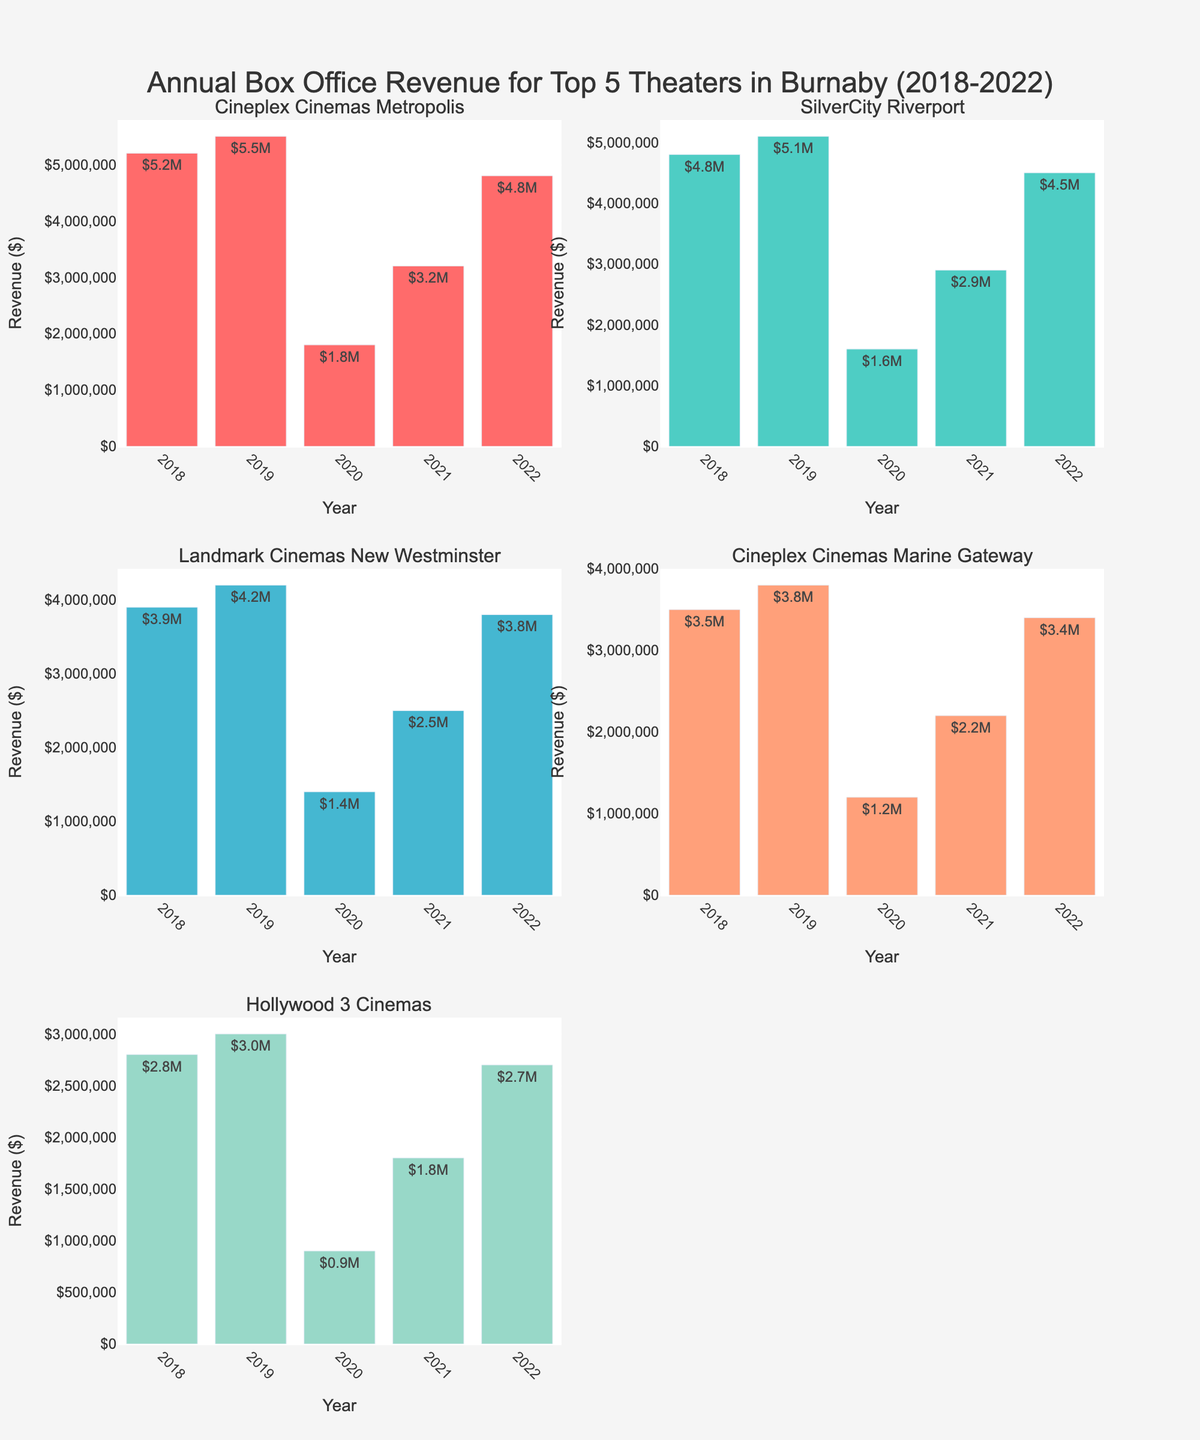What's the title of the figure? The title is placed at the top center of the figure, and it reads: "Annual Box Office Revenue for Top 5 Theaters in Burnaby (2018-2022)".
Answer: Annual Box Office Revenue for Top 5 Theaters in Burnaby (2018-2022) Which theater had the highest revenue in 2019? By looking at the height of the bars for the year 2019, we can see that the highest revenue was from Cineplex Cinemas Metropolis.
Answer: Cineplex Cinemas Metropolis What trend is visible for all theaters in 2020? The bars for all theaters in the year 2020 are significantly lower than in other years, indicating a drop in revenue for all theaters.
Answer: Drop in revenue How does Cineplex Cinemas Marine Gateway's revenue in 2022 compare to its revenue in 2018? The revenue in 2022 is $3.4M, and in 2018 it is $3.5M. The revenue has slightly decreased over these years.
Answer: Slight decrease Which theater saw the largest recovery in revenue from 2020 to 2022? Calculate the difference in revenue from 2020 to 2022 for each theater. The largest difference is for Cineplex Cinemas Metropolis, with an increase from $1.8M to $4.8M, a $3M increase.
Answer: Cineplex Cinemas Metropolis Compare the revenue trend of Hollywood 3 Cinemas and SilverCity Riverport from 2018 to 2022? Hollywood 3 Cinemas: revenue decreases in 2020 and rises gradually again by 2022. SilverCity Riverport: similar dip in 2020 but rebounds more steadily by 2022. Both follow a U-shaped pattern.
Answer: U-shaped pattern for both What was the total revenue of Landmark Cinemas New Westminster over the 5 years? Sum the revenues from 2018 to 2022: $3.9M + $4.2M + $1.4M + $2.5M + $3.8M = $15.8M.
Answer: $15.8M Which theater showed the least amount of revenue change over the 5 years? By examining all bars, Cineplex Cinemas Marine Gateway showed relatively small changes in revenue compared to other theaters.
Answer: Cineplex Cinemas Marine Gateway How did SilverCity Riverport perform in 2021 compared to Cineplex Cinemas Metropolis in the same year? In 2021, SilverCity Riverport had a revenue of $2.9M, while Cineplex Cinemas Metropolis had $3.2M. Thus, Cineplex Cinemas Metropolis performed slightly better.
Answer: Cineplex Cinemas Metropolis performed better What was the average annual revenue for Hollywood 3 Cinemas over the 5 years? Sum all revenues for Hollywood 3 Cinemas and divide by 5: ($2.8M + $3.0M + $0.9M + $1.8M + $2.7M) / 5 = $2.24M.
Answer: $2.24M 